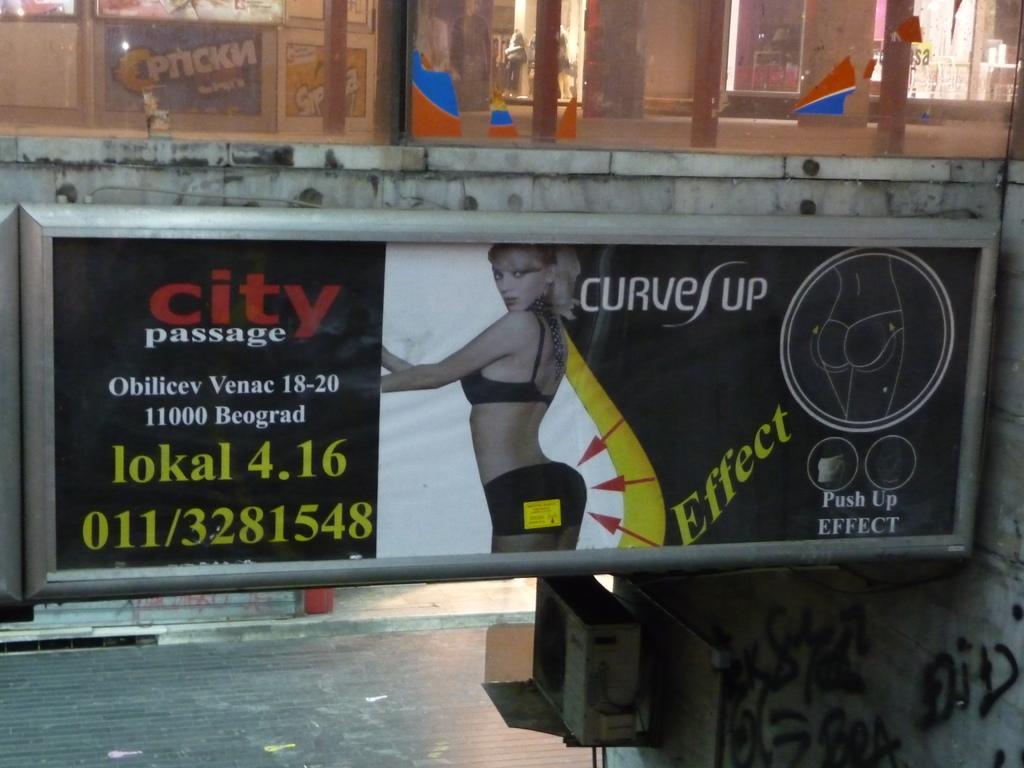Could you give a brief overview of what you see in this image? In the image we can see a poster, in the poster we can see a girl standing. This is a glass window and a floor, this is a printed text. 